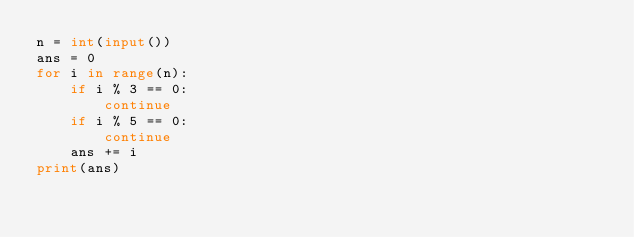<code> <loc_0><loc_0><loc_500><loc_500><_Python_>n = int(input())
ans = 0
for i in range(n):
    if i % 3 == 0:
        continue
    if i % 5 == 0:
        continue
    ans += i
print(ans)
</code> 